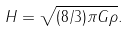<formula> <loc_0><loc_0><loc_500><loc_500>H = \sqrt { ( 8 / 3 ) \pi G \rho } .</formula> 